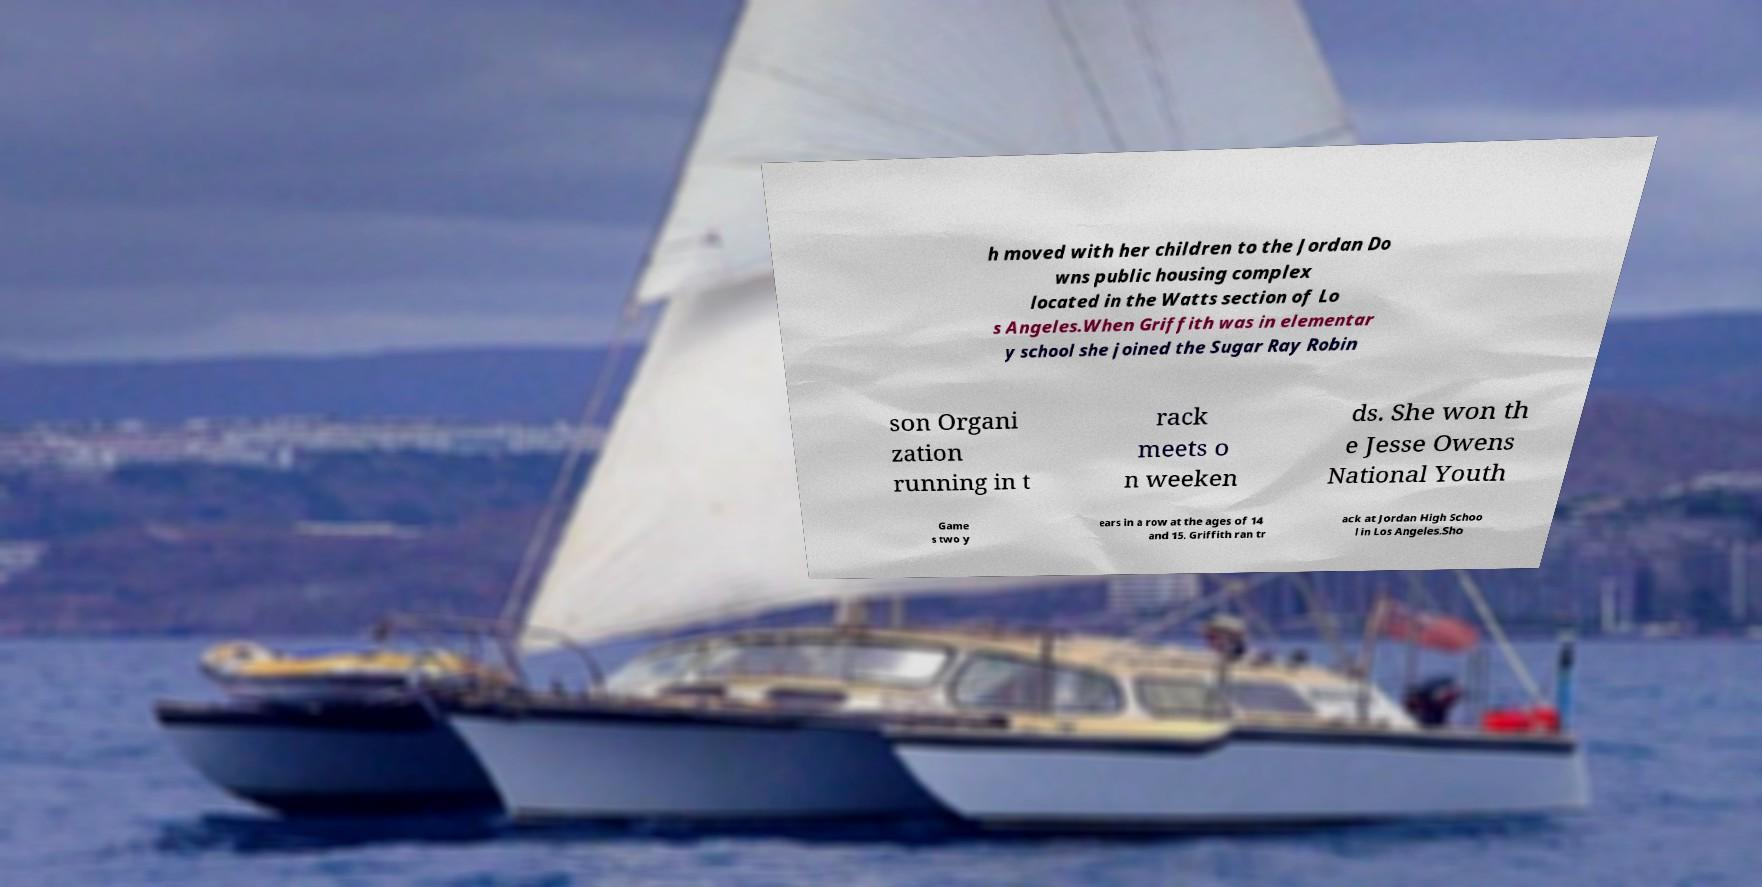I need the written content from this picture converted into text. Can you do that? h moved with her children to the Jordan Do wns public housing complex located in the Watts section of Lo s Angeles.When Griffith was in elementar y school she joined the Sugar Ray Robin son Organi zation running in t rack meets o n weeken ds. She won th e Jesse Owens National Youth Game s two y ears in a row at the ages of 14 and 15. Griffith ran tr ack at Jordan High Schoo l in Los Angeles.Sho 